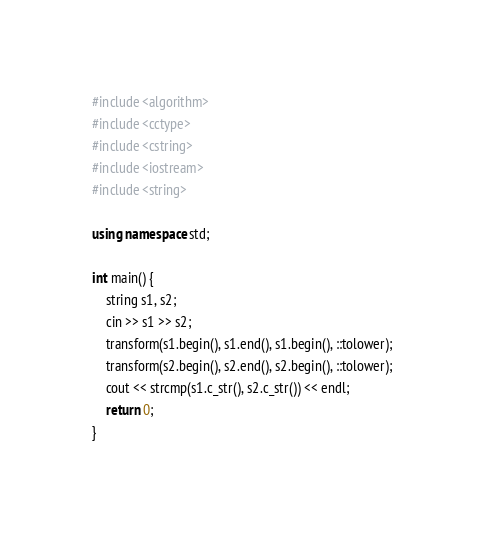Convert code to text. <code><loc_0><loc_0><loc_500><loc_500><_C++_>#include <algorithm>
#include <cctype>
#include <cstring>
#include <iostream>
#include <string>

using namespace std;

int main() {
    string s1, s2;
    cin >> s1 >> s2;
    transform(s1.begin(), s1.end(), s1.begin(), ::tolower);
    transform(s2.begin(), s2.end(), s2.begin(), ::tolower);
    cout << strcmp(s1.c_str(), s2.c_str()) << endl;
    return 0;
}</code> 